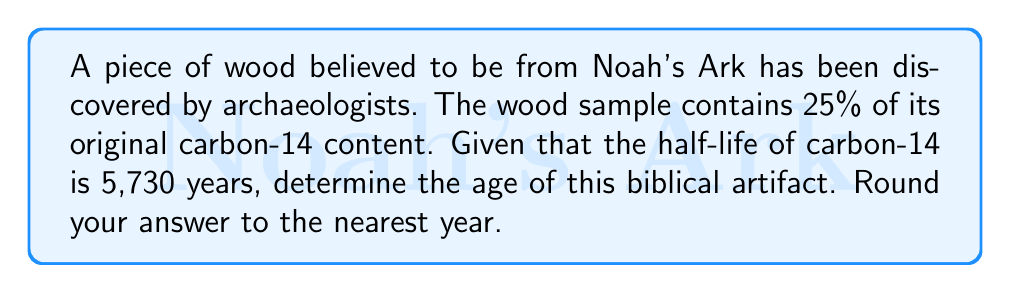Can you solve this math problem? To solve this problem, we'll use the radioactive decay formula and the given information:

1) The general formula for radioactive decay is:
   $$ N(t) = N_0 \cdot (0.5)^{t/t_{1/2}} $$
   Where:
   $N(t)$ is the amount remaining after time $t$
   $N_0$ is the initial amount
   $t$ is the time elapsed
   $t_{1/2}$ is the half-life

2) We know that 25% of the original carbon-14 remains, so:
   $$ 0.25 = (0.5)^{t/5730} $$

3) Taking the natural log of both sides:
   $$ \ln(0.25) = \ln((0.5)^{t/5730}) $$

4) Using the logarithm property $\ln(a^b) = b\ln(a)$:
   $$ \ln(0.25) = \frac{t}{5730} \cdot \ln(0.5) $$

5) Solving for $t$:
   $$ t = 5730 \cdot \frac{\ln(0.25)}{\ln(0.5)} $$

6) Calculate:
   $$ t = 5730 \cdot \frac{-1.3862943611198906}{-0.6931471805599453} $$
   $$ t = 11460.47... $$

7) Rounding to the nearest year:
   $$ t \approx 11,460 \text{ years} $$

This calculation reveals the age of the artifact, demonstrating the harmony between scientific methods and biblical accounts of Earth's history.
Answer: 11,460 years 